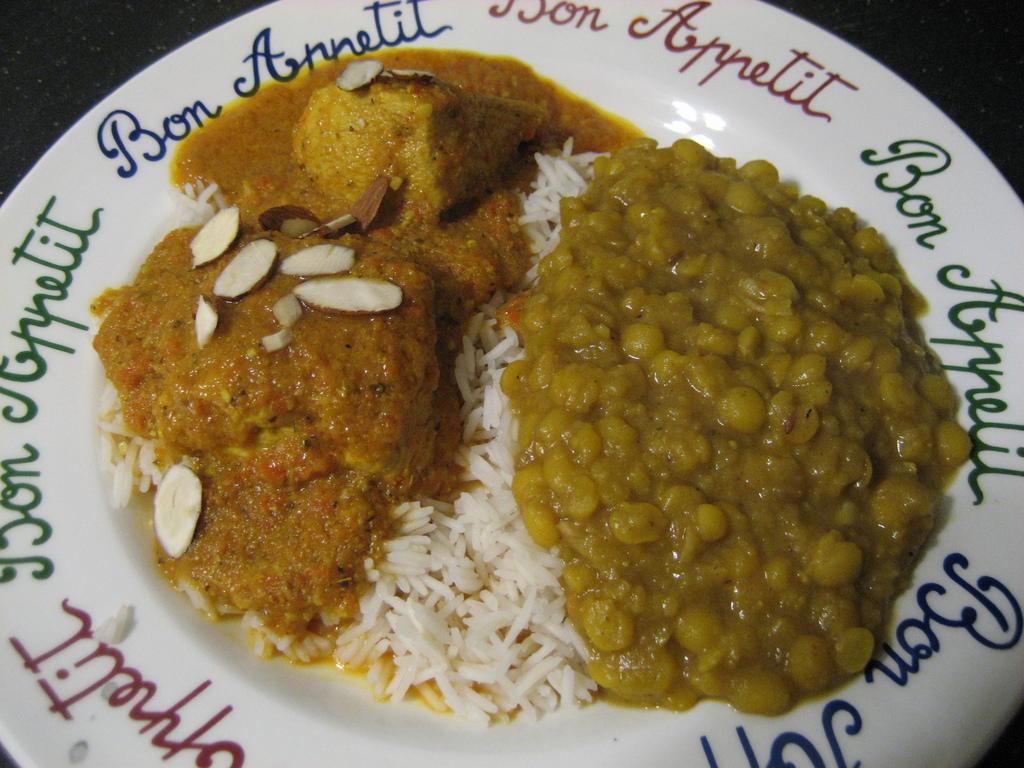Can you describe this image briefly? In this image, I can see a plate with letters on it. I can see rice, curry, dry fruits and few other items on it. The background looks dark. 